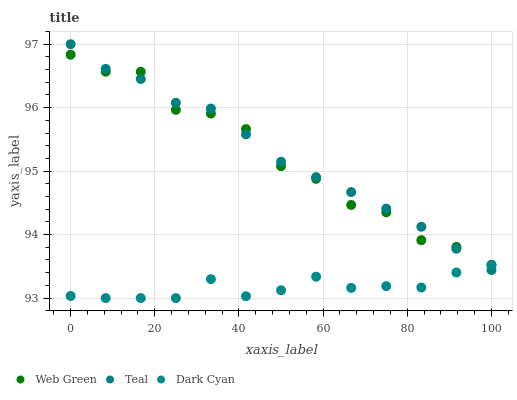Does Dark Cyan have the minimum area under the curve?
Answer yes or no. Yes. Does Teal have the maximum area under the curve?
Answer yes or no. Yes. Does Web Green have the minimum area under the curve?
Answer yes or no. No. Does Web Green have the maximum area under the curve?
Answer yes or no. No. Is Teal the smoothest?
Answer yes or no. Yes. Is Web Green the roughest?
Answer yes or no. Yes. Is Web Green the smoothest?
Answer yes or no. No. Is Teal the roughest?
Answer yes or no. No. Does Dark Cyan have the lowest value?
Answer yes or no. Yes. Does Teal have the lowest value?
Answer yes or no. No. Does Teal have the highest value?
Answer yes or no. Yes. Does Web Green have the highest value?
Answer yes or no. No. Does Dark Cyan intersect Web Green?
Answer yes or no. Yes. Is Dark Cyan less than Web Green?
Answer yes or no. No. Is Dark Cyan greater than Web Green?
Answer yes or no. No. 